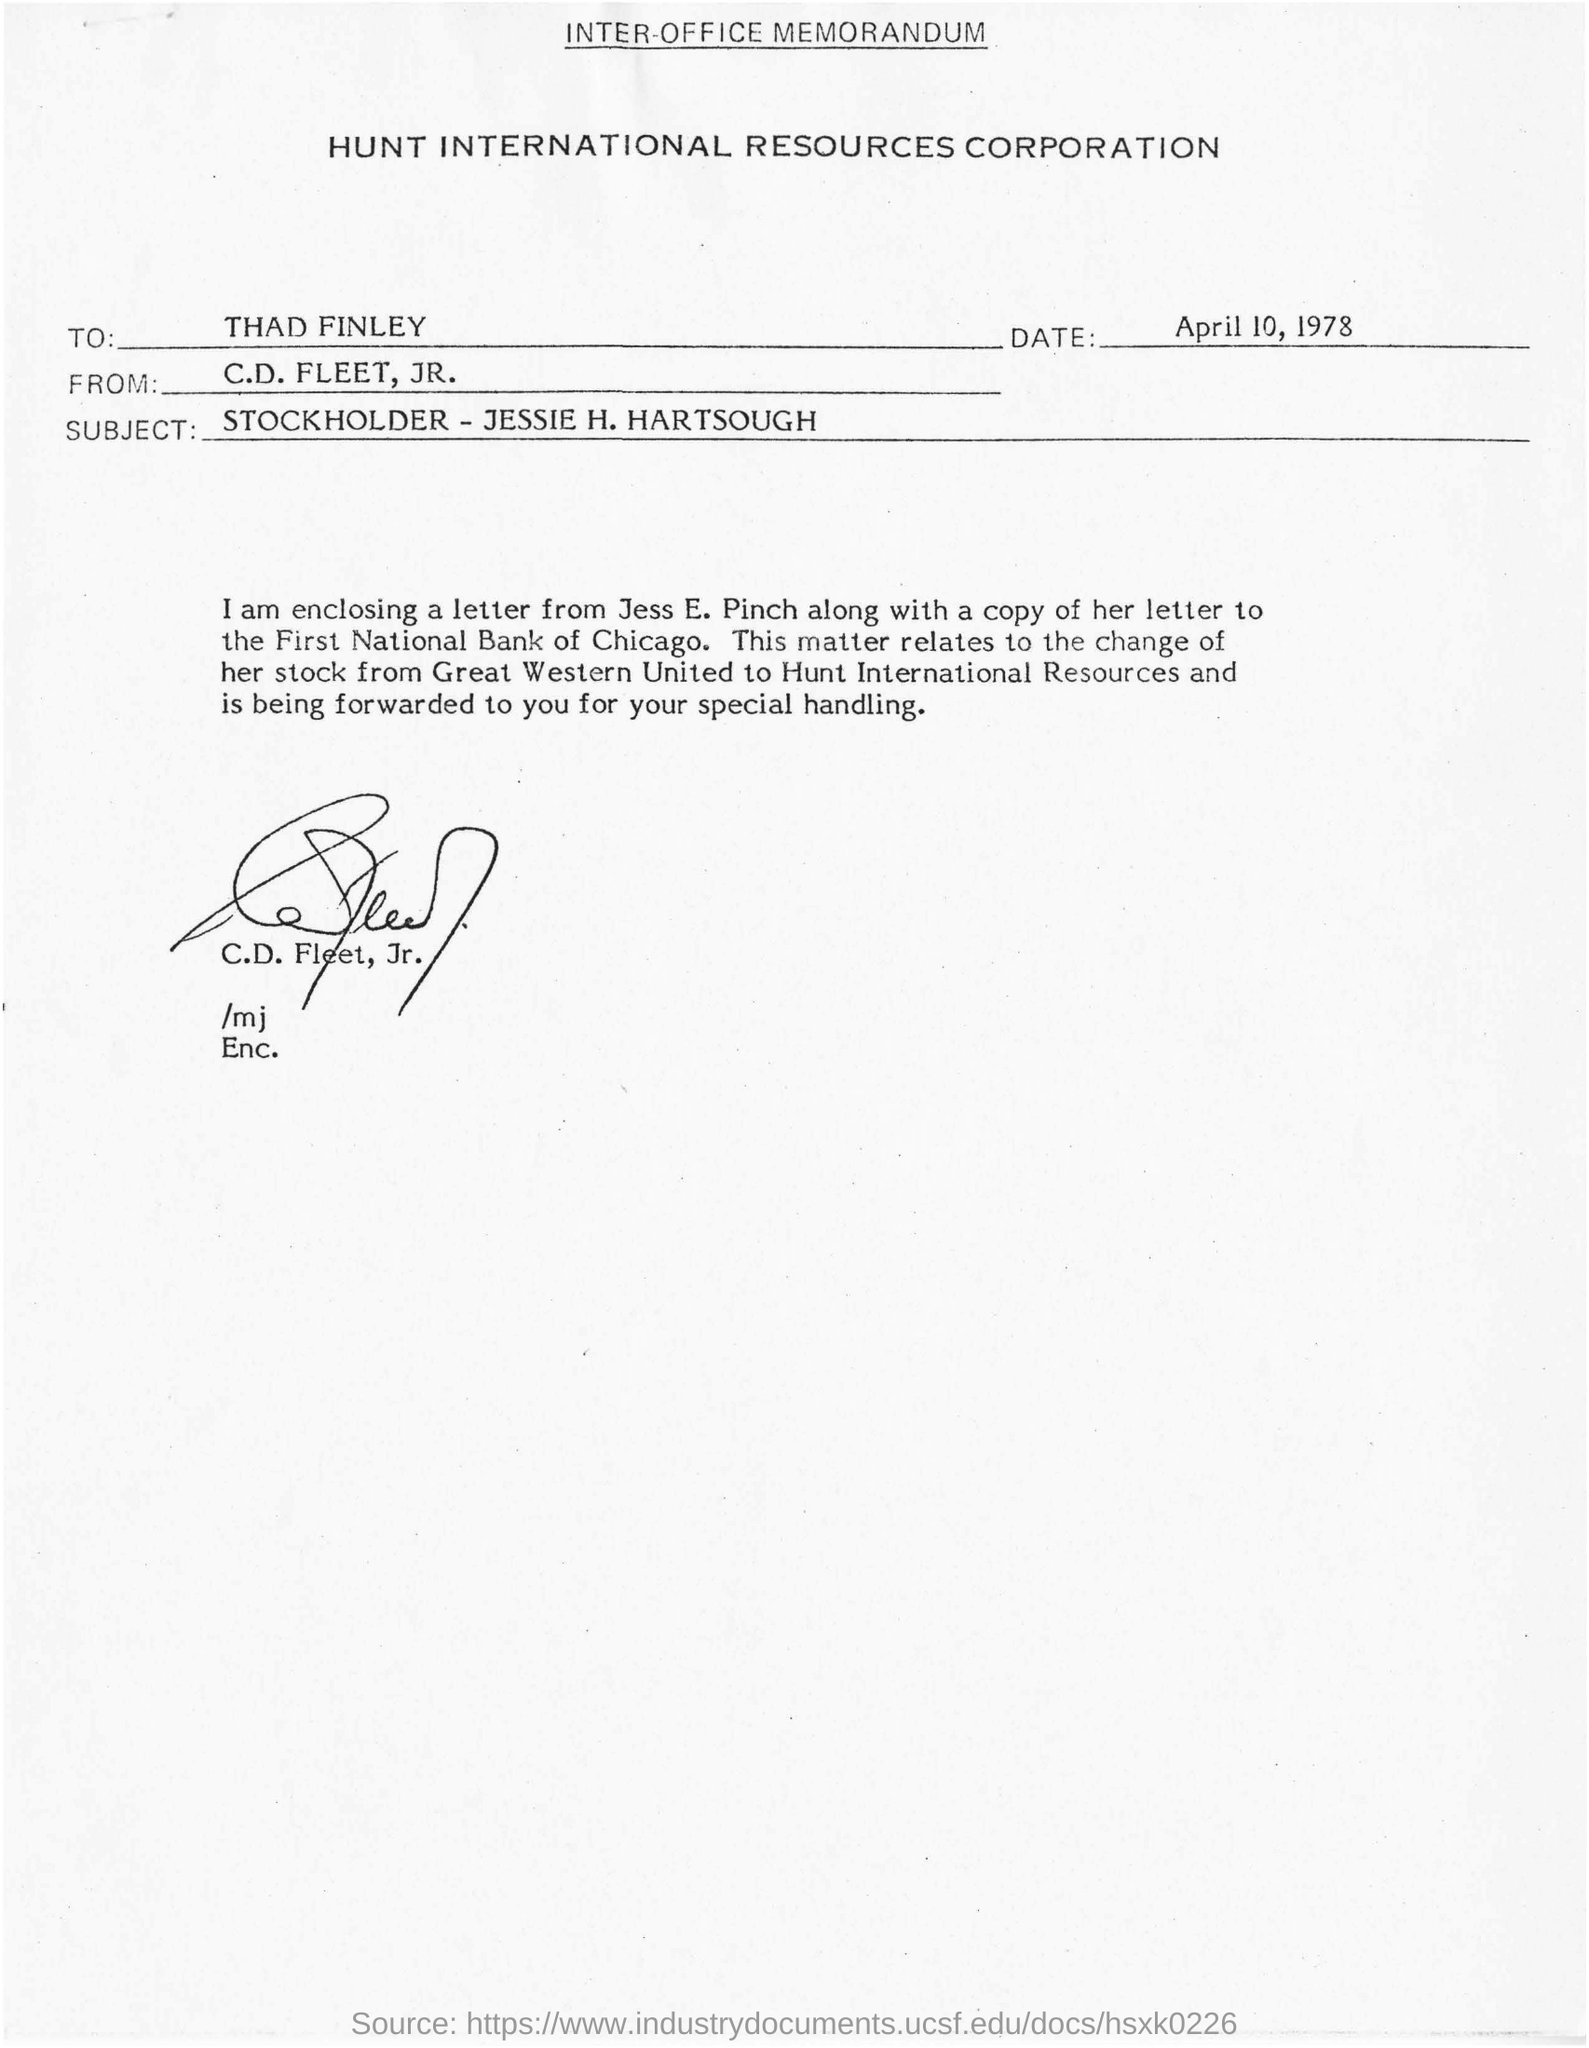Outline some significant characteristics in this image. The memorandum was written to Thad Finley. The date mentioned in the given page is April 10, 1978. The person who sent the memorandum is C.D. Fleet, Jr. The signature at the bottom of the letter was that of C.D. Fleet, Jr. Hunt International Resources Corporation is the name of the corporation mentioned. 